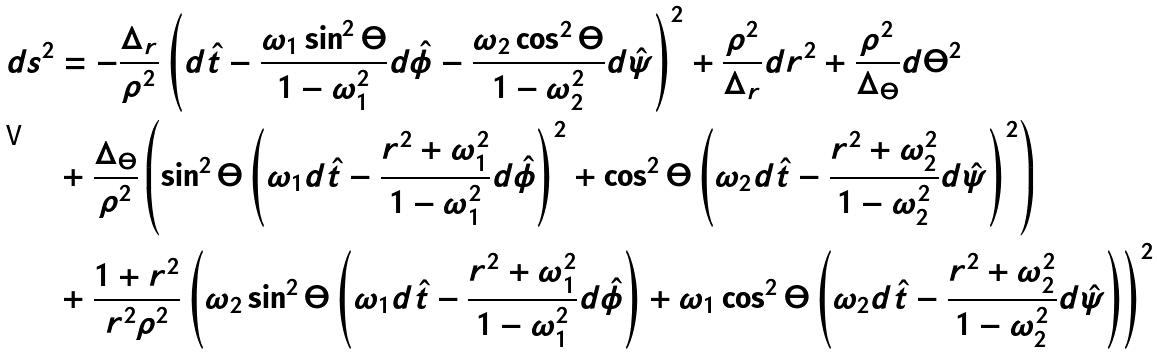Convert formula to latex. <formula><loc_0><loc_0><loc_500><loc_500>d s ^ { 2 } & = - \frac { \Delta _ { r } } { \rho ^ { 2 } } \left ( d \hat { t } - \frac { \omega _ { 1 } \sin ^ { 2 } \Theta } { 1 - \omega _ { 1 } ^ { 2 } } d \hat { \phi } - \frac { \omega _ { 2 } \cos ^ { 2 } \Theta } { 1 - \omega _ { 2 } ^ { 2 } } d \hat { \psi } \right ) ^ { 2 } + \frac { \rho ^ { 2 } } { \Delta _ { r } } d r ^ { 2 } + \frac { \rho ^ { 2 } } { \Delta _ { \Theta } } d \Theta ^ { 2 } \\ & + \frac { \Delta _ { \Theta } } { \rho ^ { 2 } } \left ( \sin ^ { 2 } \Theta \left ( \omega _ { 1 } d \hat { t } - \frac { r ^ { 2 } + \omega _ { 1 } ^ { 2 } } { 1 - \omega _ { 1 } ^ { 2 } } d \hat { \phi } \right ) ^ { 2 } + \cos ^ { 2 } \Theta \left ( \omega _ { 2 } d \hat { t } - \frac { r ^ { 2 } + \omega _ { 2 } ^ { 2 } } { 1 - \omega _ { 2 } ^ { 2 } } d \hat { \psi } \right ) ^ { 2 } \right ) \\ & + \frac { 1 + r ^ { 2 } } { r ^ { 2 } \rho ^ { 2 } } \left ( \omega _ { 2 } \sin ^ { 2 } \Theta \left ( \omega _ { 1 } d \hat { t } - \frac { r ^ { 2 } + \omega _ { 1 } ^ { 2 } } { 1 - \omega _ { 1 } ^ { 2 } } d \hat { \phi } \right ) + \omega _ { 1 } \cos ^ { 2 } \Theta \left ( \omega _ { 2 } d \hat { t } - \frac { r ^ { 2 } + \omega _ { 2 } ^ { 2 } } { 1 - \omega _ { 2 } ^ { 2 } } d \hat { \psi } \right ) \right ) ^ { 2 }</formula> 